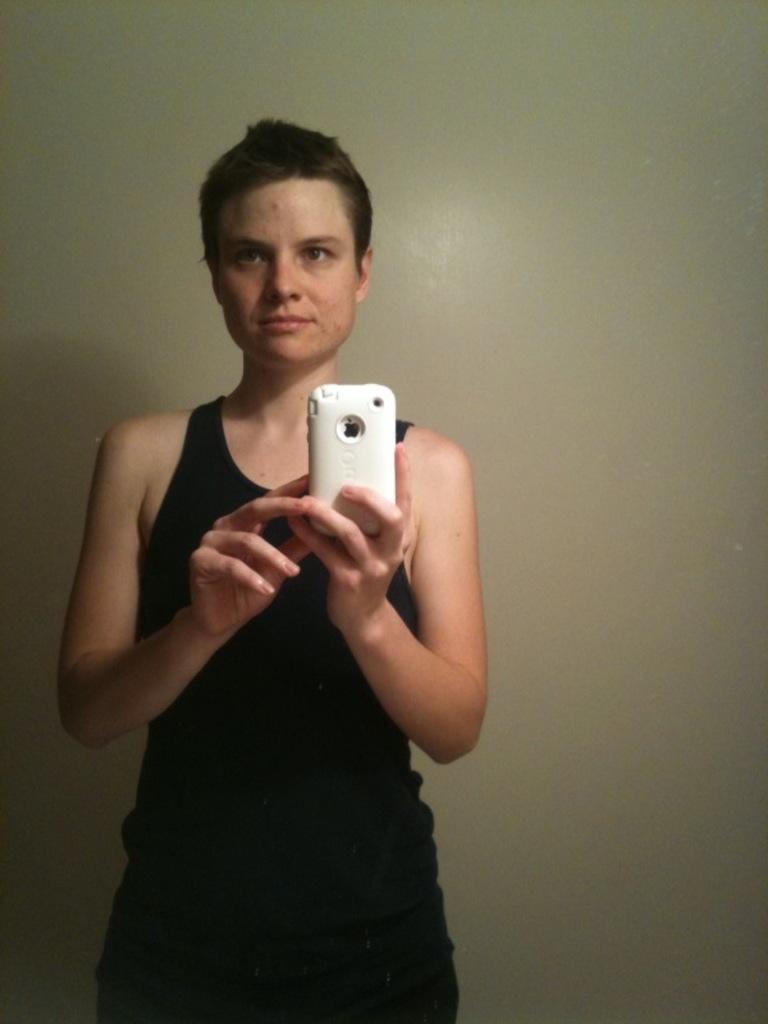Please provide a concise description of this image. In the image there is a person standing and taking the picture by holding the mobile with the hands. 